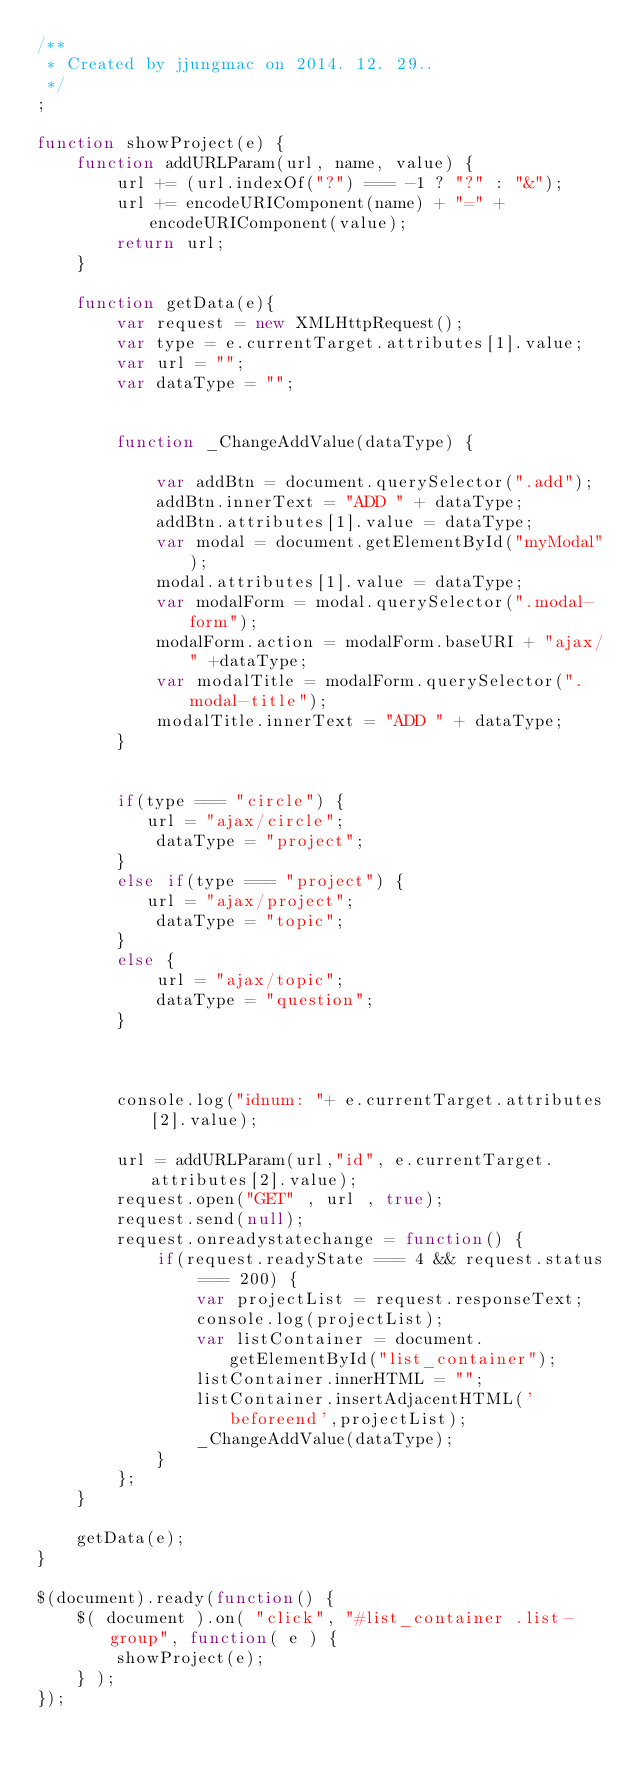<code> <loc_0><loc_0><loc_500><loc_500><_JavaScript_>/**
 * Created by jjungmac on 2014. 12. 29..
 */
;

function showProject(e) {
    function addURLParam(url, name, value) {
        url += (url.indexOf("?") === -1 ? "?" : "&");
        url += encodeURIComponent(name) + "=" + encodeURIComponent(value);
        return url;
    }

    function getData(e){
        var request = new XMLHttpRequest();
        var type = e.currentTarget.attributes[1].value;
        var url = "";
        var dataType = "";


        function _ChangeAddValue(dataType) {

            var addBtn = document.querySelector(".add");
            addBtn.innerText = "ADD " + dataType;
            addBtn.attributes[1].value = dataType;
            var modal = document.getElementById("myModal");
            modal.attributes[1].value = dataType;
            var modalForm = modal.querySelector(".modal-form");
            modalForm.action = modalForm.baseURI + "ajax/" +dataType;
            var modalTitle = modalForm.querySelector(".modal-title");
            modalTitle.innerText = "ADD " + dataType;
        }


        if(type === "circle") {
           url = "ajax/circle";
            dataType = "project";
        }
        else if(type === "project") {
           url = "ajax/project";
            dataType = "topic";
        }
        else {
            url = "ajax/topic";
            dataType = "question";
        }



        console.log("idnum: "+ e.currentTarget.attributes[2].value);

        url = addURLParam(url,"id", e.currentTarget.attributes[2].value);
        request.open("GET" , url , true);
        request.send(null);
        request.onreadystatechange = function() {
            if(request.readyState === 4 && request.status === 200) {
                var projectList = request.responseText;
                console.log(projectList);
                var listContainer = document.getElementById("list_container");
                listContainer.innerHTML = "";
                listContainer.insertAdjacentHTML('beforeend',projectList);
                _ChangeAddValue(dataType);
            }
        };
    }

    getData(e);
}

$(document).ready(function() {
    $( document ).on( "click", "#list_container .list-group", function( e ) {
        showProject(e);
    } );
});
</code> 